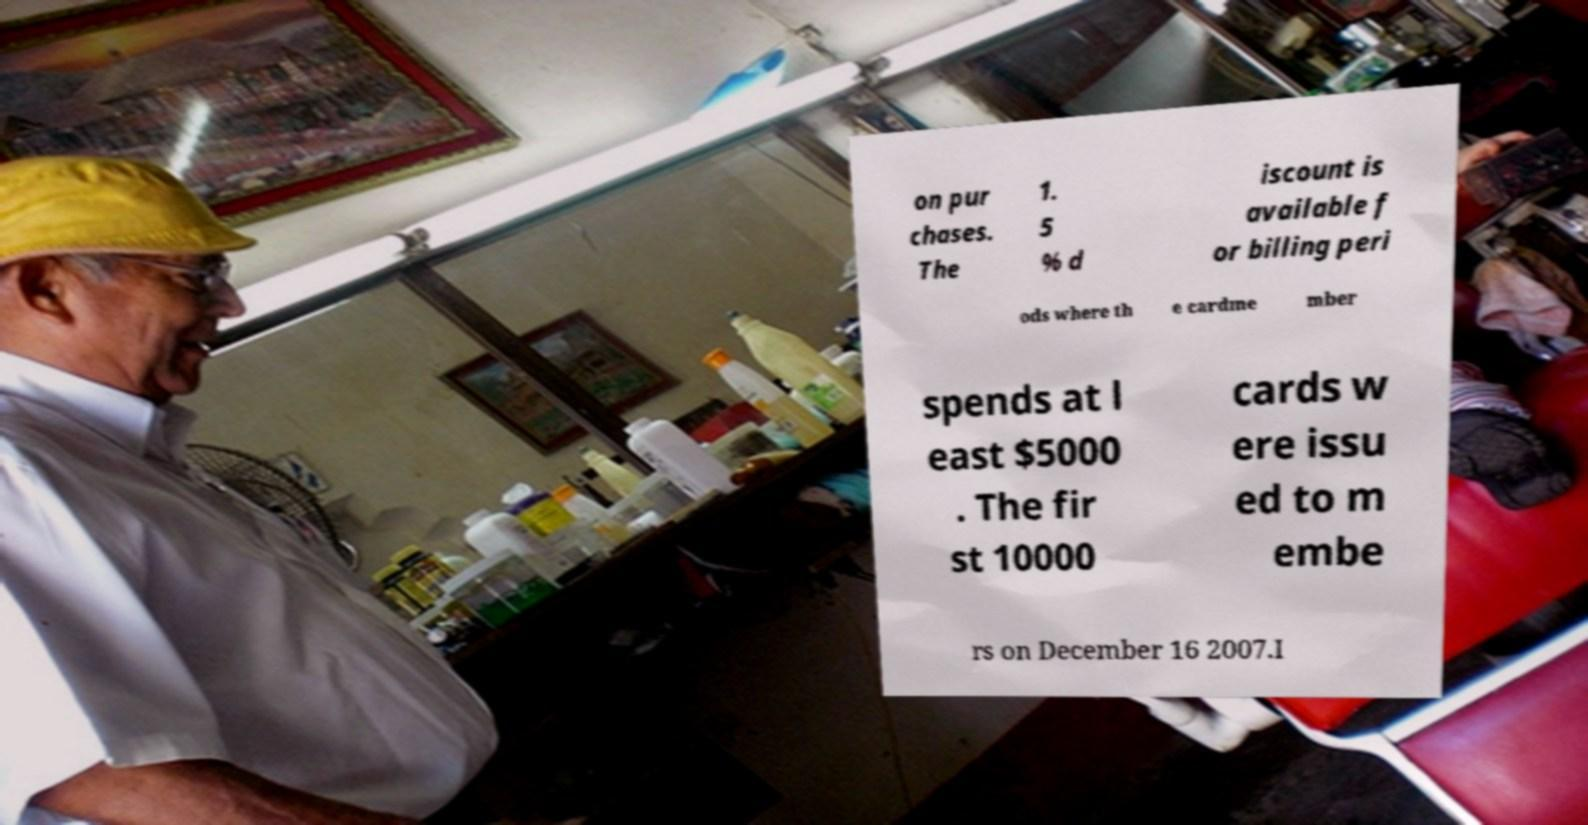I need the written content from this picture converted into text. Can you do that? on pur chases. The 1. 5 % d iscount is available f or billing peri ods where th e cardme mber spends at l east $5000 . The fir st 10000 cards w ere issu ed to m embe rs on December 16 2007.I 